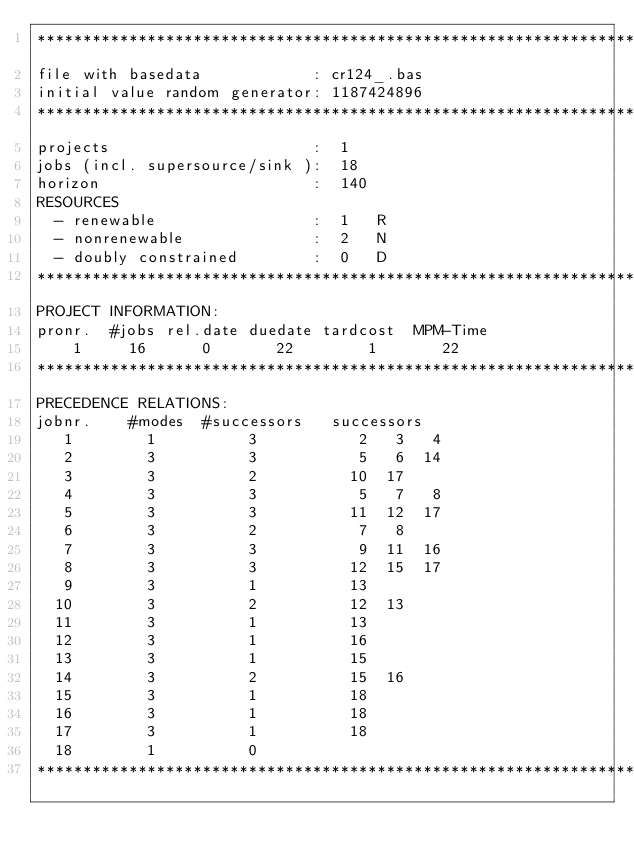<code> <loc_0><loc_0><loc_500><loc_500><_ObjectiveC_>************************************************************************
file with basedata            : cr124_.bas
initial value random generator: 1187424896
************************************************************************
projects                      :  1
jobs (incl. supersource/sink ):  18
horizon                       :  140
RESOURCES
  - renewable                 :  1   R
  - nonrenewable              :  2   N
  - doubly constrained        :  0   D
************************************************************************
PROJECT INFORMATION:
pronr.  #jobs rel.date duedate tardcost  MPM-Time
    1     16      0       22        1       22
************************************************************************
PRECEDENCE RELATIONS:
jobnr.    #modes  #successors   successors
   1        1          3           2   3   4
   2        3          3           5   6  14
   3        3          2          10  17
   4        3          3           5   7   8
   5        3          3          11  12  17
   6        3          2           7   8
   7        3          3           9  11  16
   8        3          3          12  15  17
   9        3          1          13
  10        3          2          12  13
  11        3          1          13
  12        3          1          16
  13        3          1          15
  14        3          2          15  16
  15        3          1          18
  16        3          1          18
  17        3          1          18
  18        1          0        
************************************************************************</code> 